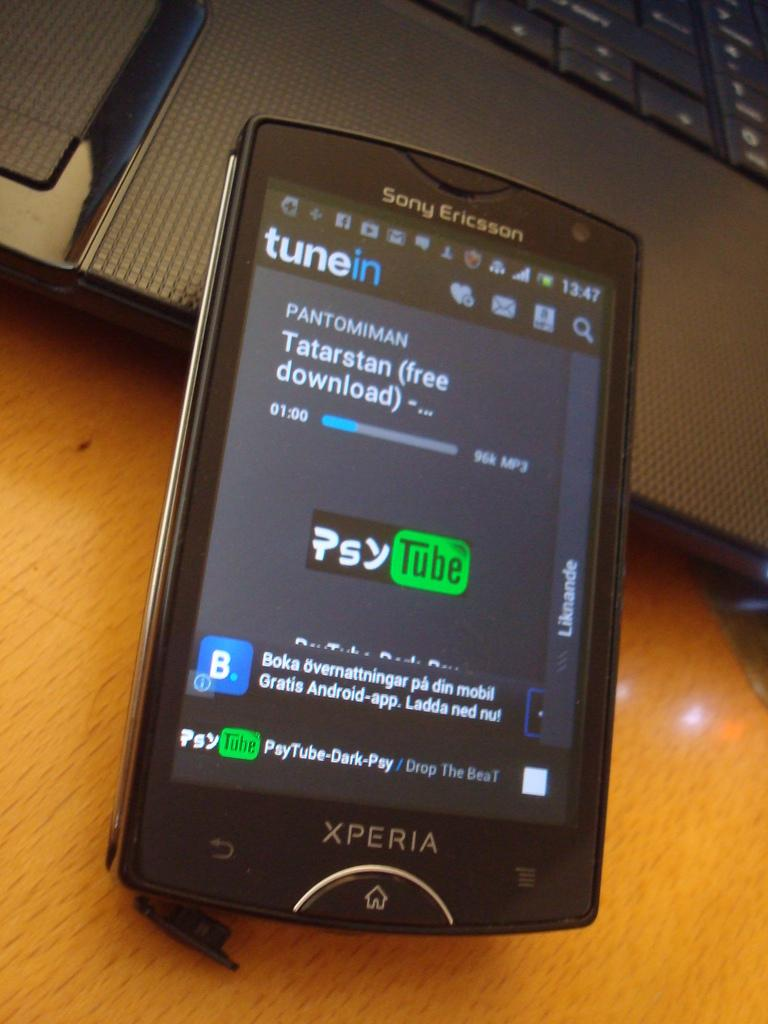<image>
Summarize the visual content of the image. sony ericsson xperia phone running tunein app against front of laptop 